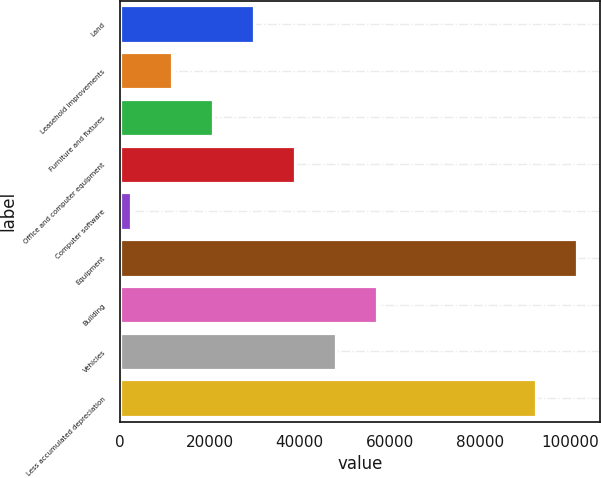Convert chart to OTSL. <chart><loc_0><loc_0><loc_500><loc_500><bar_chart><fcel>Land<fcel>Leasehold improvements<fcel>Furniture and fixtures<fcel>Office and computer equipment<fcel>Computer software<fcel>Equipment<fcel>Building<fcel>Vehicles<fcel>Less accumulated depreciation<nl><fcel>29810.5<fcel>11623.5<fcel>20717<fcel>38904<fcel>2530<fcel>101614<fcel>57091<fcel>47997.5<fcel>92520<nl></chart> 